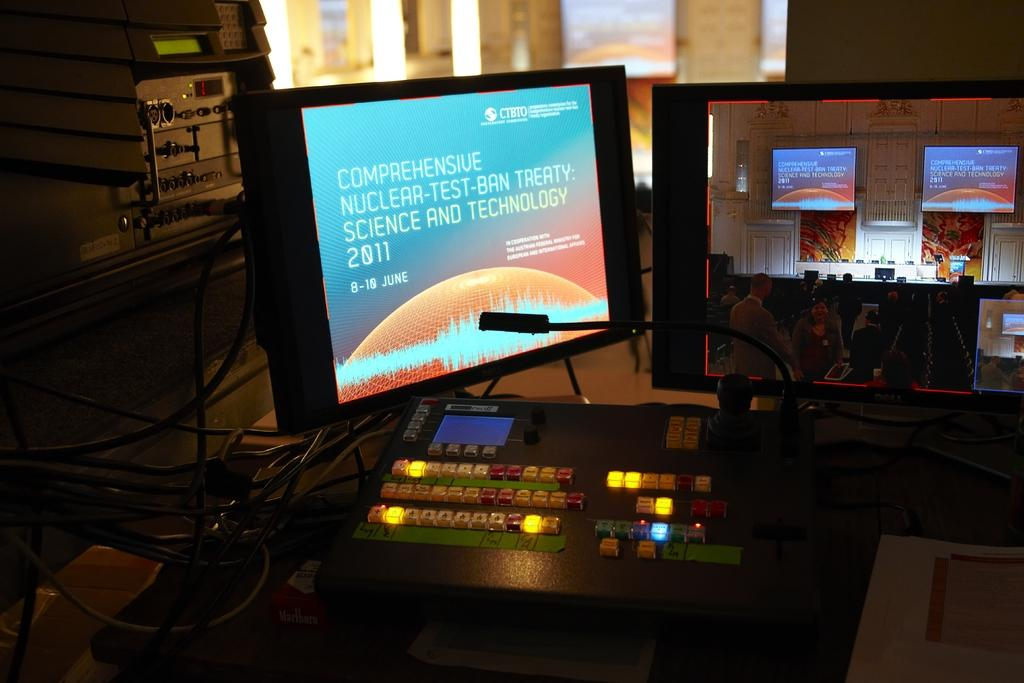Provide a one-sentence caption for the provided image. A computer displaying comprehensive nuclear-test-ban treaty science and technology. 